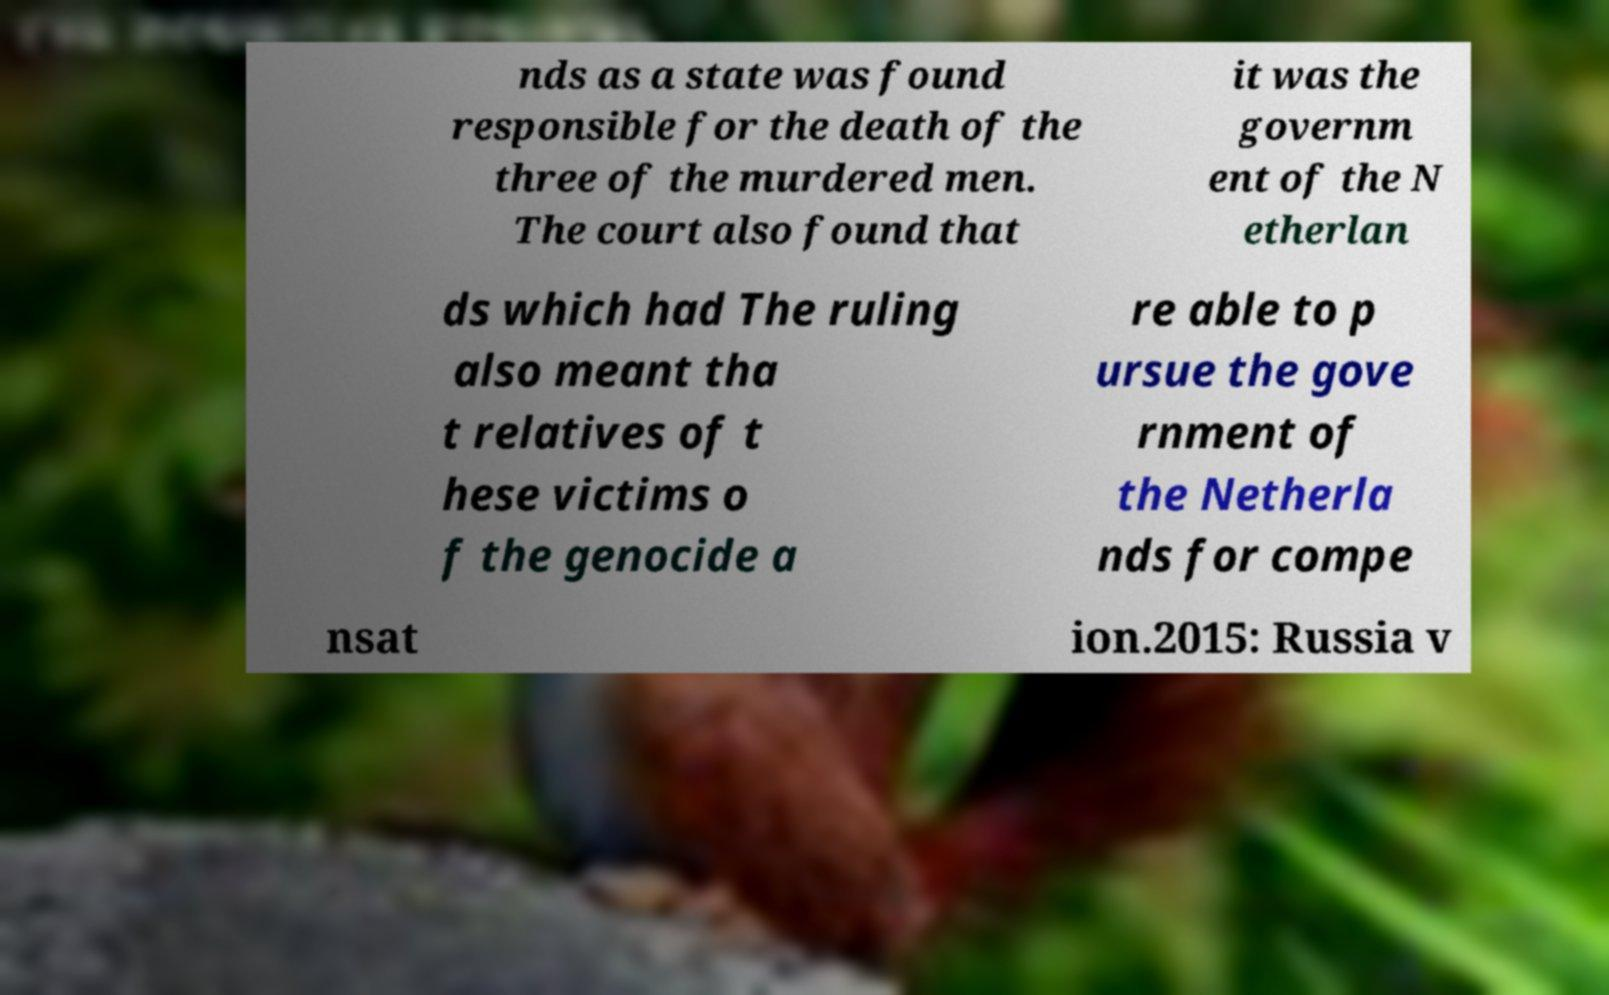Can you accurately transcribe the text from the provided image for me? nds as a state was found responsible for the death of the three of the murdered men. The court also found that it was the governm ent of the N etherlan ds which had The ruling also meant tha t relatives of t hese victims o f the genocide a re able to p ursue the gove rnment of the Netherla nds for compe nsat ion.2015: Russia v 